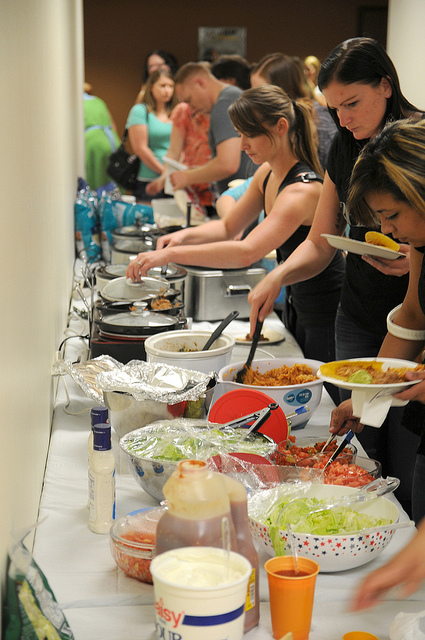What might be the reason for the choice of foods presented? The choice of foods, which includes a variety of salads, pasta, and potentially finger foods, suggests an intention to cater to diverse tastes and possibly dietary restrictions. Such a selection allows for easy serving and consumption, fitting for the casual and communal nature of the event. It's likely designed for people to enjoy a balanced meal while socializing. 